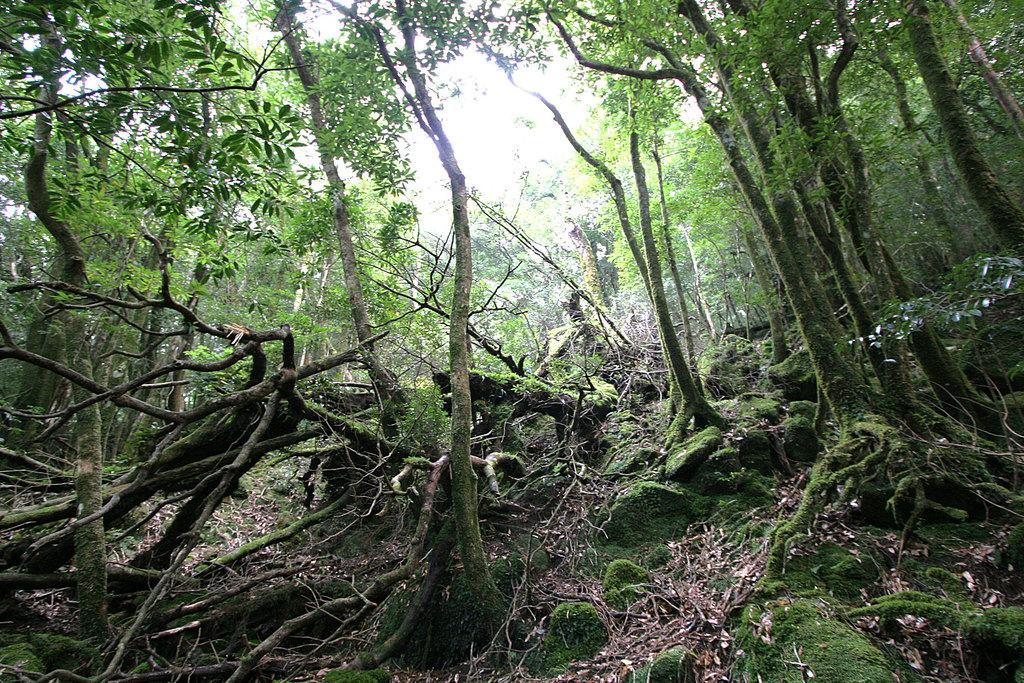Could you give a brief overview of what you see in this image? In the background of the image we can see the trees. At the bottom of the image we can see the dry leaves, algae. At the top of the image we can see the sky. 